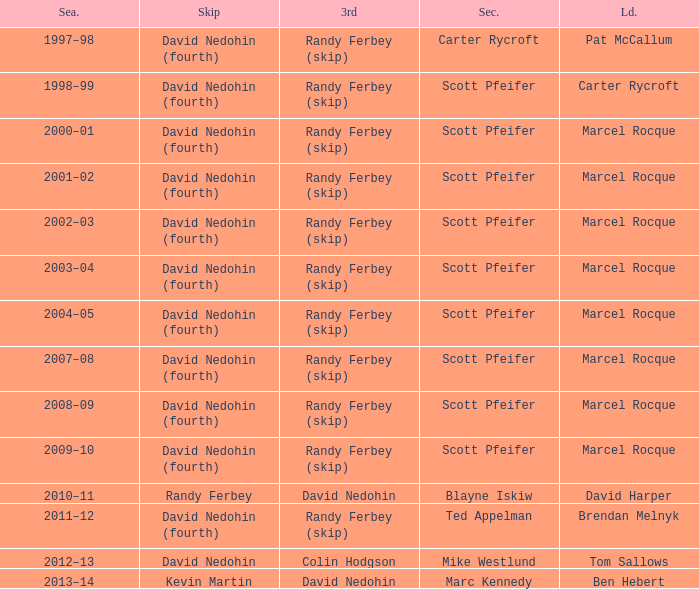Which Third has a Second of scott pfeifer? Randy Ferbey (skip), Randy Ferbey (skip), Randy Ferbey (skip), Randy Ferbey (skip), Randy Ferbey (skip), Randy Ferbey (skip), Randy Ferbey (skip), Randy Ferbey (skip), Randy Ferbey (skip). 